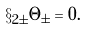Convert formula to latex. <formula><loc_0><loc_0><loc_500><loc_500>\S _ { 2 \pm } \Theta _ { \pm } = 0 .</formula> 